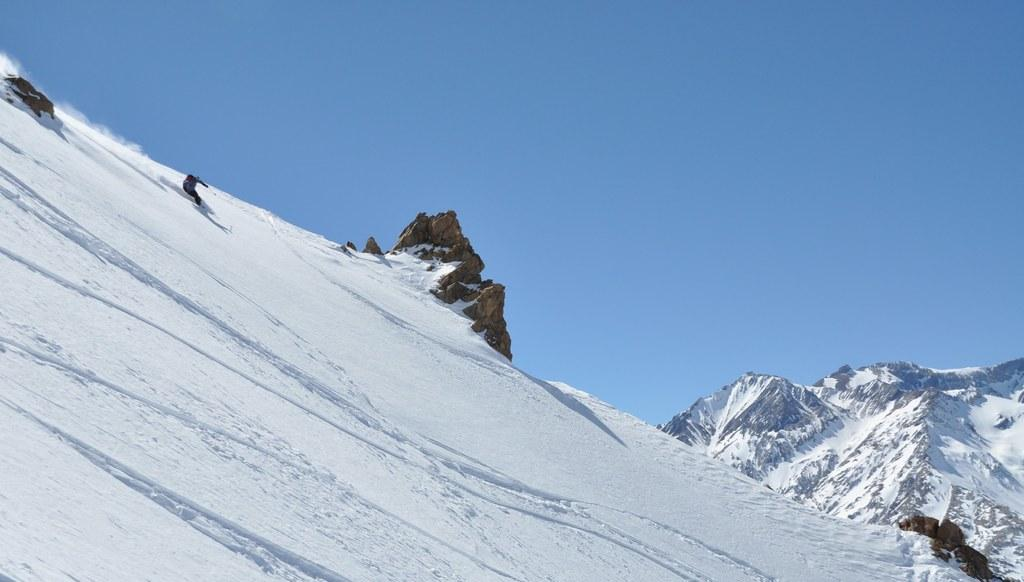What is the main subject of the image? The main subject of the image is a mountain. What is the condition of the mountain in the image? The mountain is covered with snow. What can be seen in the background of the image? There is a blue sky visible in the background of the image. Can you tell me how many robins are participating in the competition on the mountain? There are no robins or competitions present in the image; it features a snow-covered mountain with a blue sky in the background. 